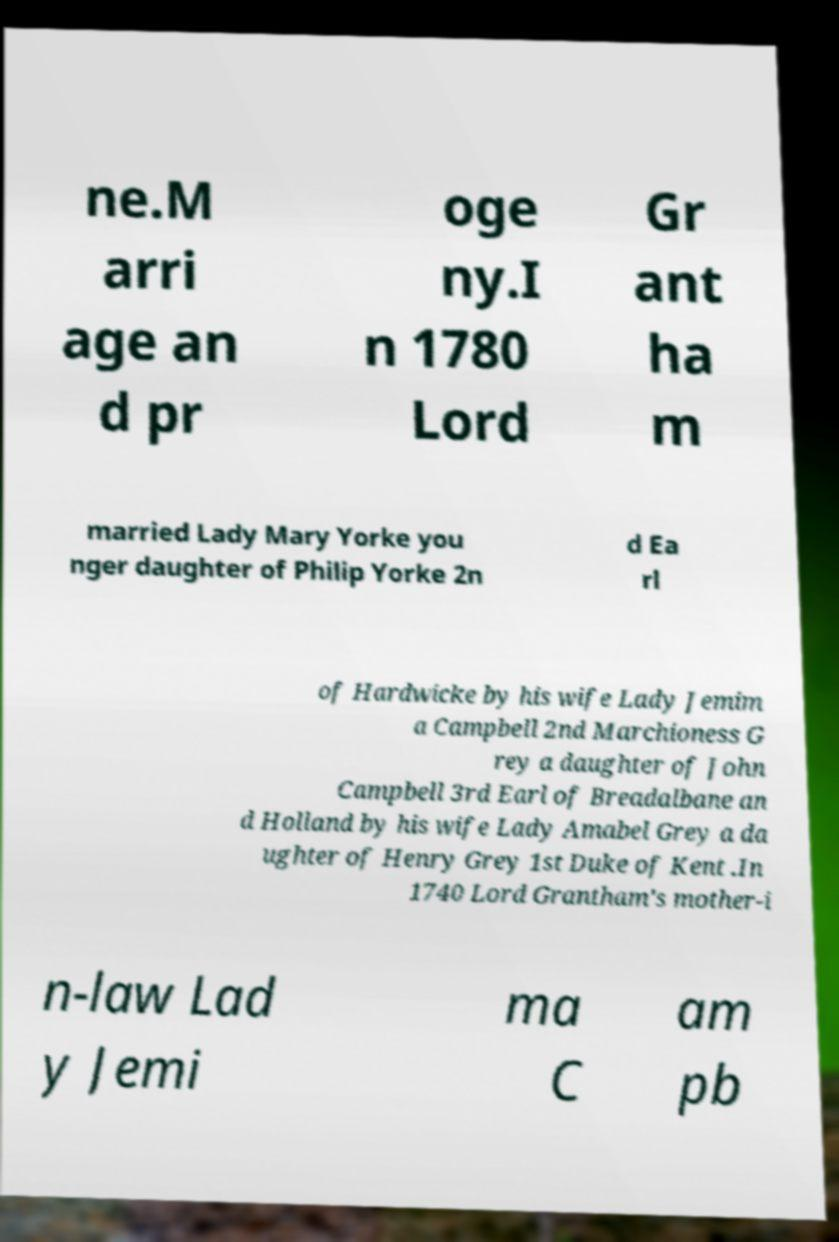What messages or text are displayed in this image? I need them in a readable, typed format. ne.M arri age an d pr oge ny.I n 1780 Lord Gr ant ha m married Lady Mary Yorke you nger daughter of Philip Yorke 2n d Ea rl of Hardwicke by his wife Lady Jemim a Campbell 2nd Marchioness G rey a daughter of John Campbell 3rd Earl of Breadalbane an d Holland by his wife Lady Amabel Grey a da ughter of Henry Grey 1st Duke of Kent .In 1740 Lord Grantham's mother-i n-law Lad y Jemi ma C am pb 